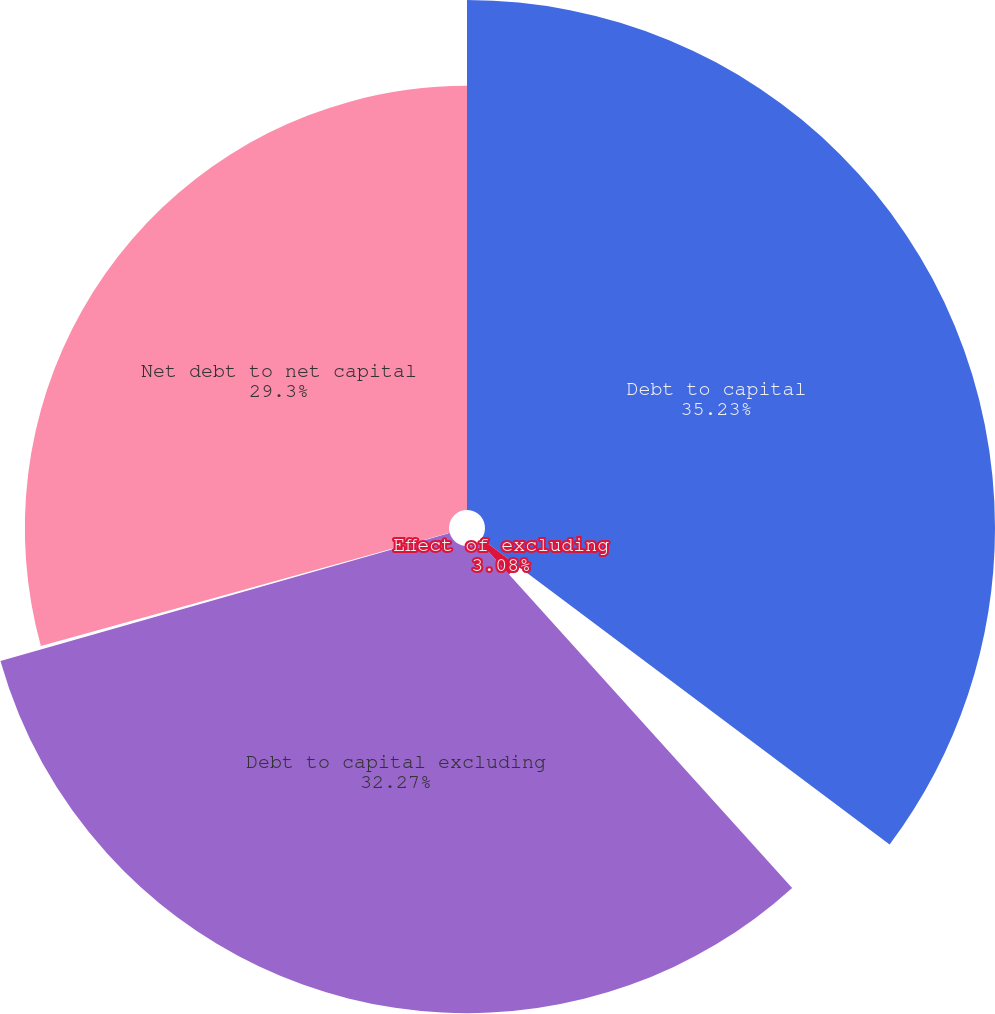<chart> <loc_0><loc_0><loc_500><loc_500><pie_chart><fcel>Debt to capital<fcel>Effect of excluding<fcel>Debt to capital excluding<fcel>Effect of subtracting cash<fcel>Net debt to net capital<nl><fcel>35.23%<fcel>3.08%<fcel>32.27%<fcel>0.12%<fcel>29.3%<nl></chart> 